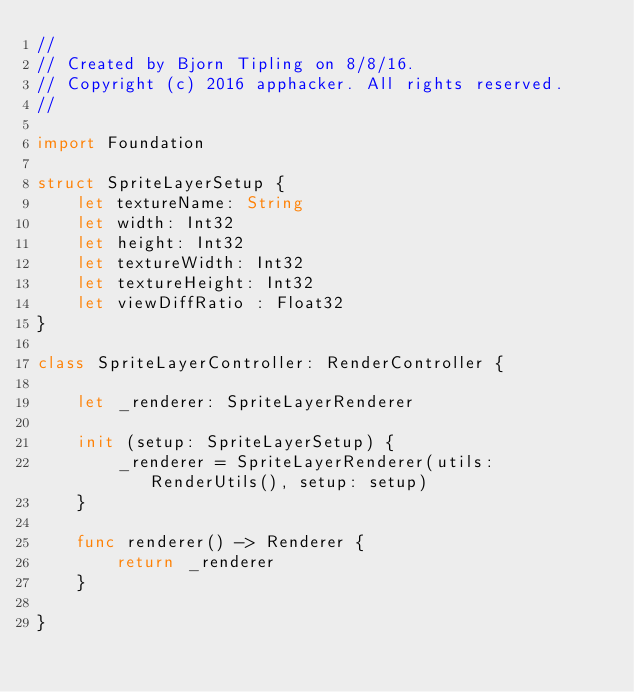Convert code to text. <code><loc_0><loc_0><loc_500><loc_500><_Swift_>//
// Created by Bjorn Tipling on 8/8/16.
// Copyright (c) 2016 apphacker. All rights reserved.
//

import Foundation

struct SpriteLayerSetup {
    let textureName: String
    let width: Int32
    let height: Int32
    let textureWidth: Int32
    let textureHeight: Int32
    let viewDiffRatio : Float32
}

class SpriteLayerController: RenderController {

    let _renderer: SpriteLayerRenderer

    init (setup: SpriteLayerSetup) {
        _renderer = SpriteLayerRenderer(utils: RenderUtils(), setup: setup)
    }

    func renderer() -> Renderer {
        return _renderer
    }

}
</code> 